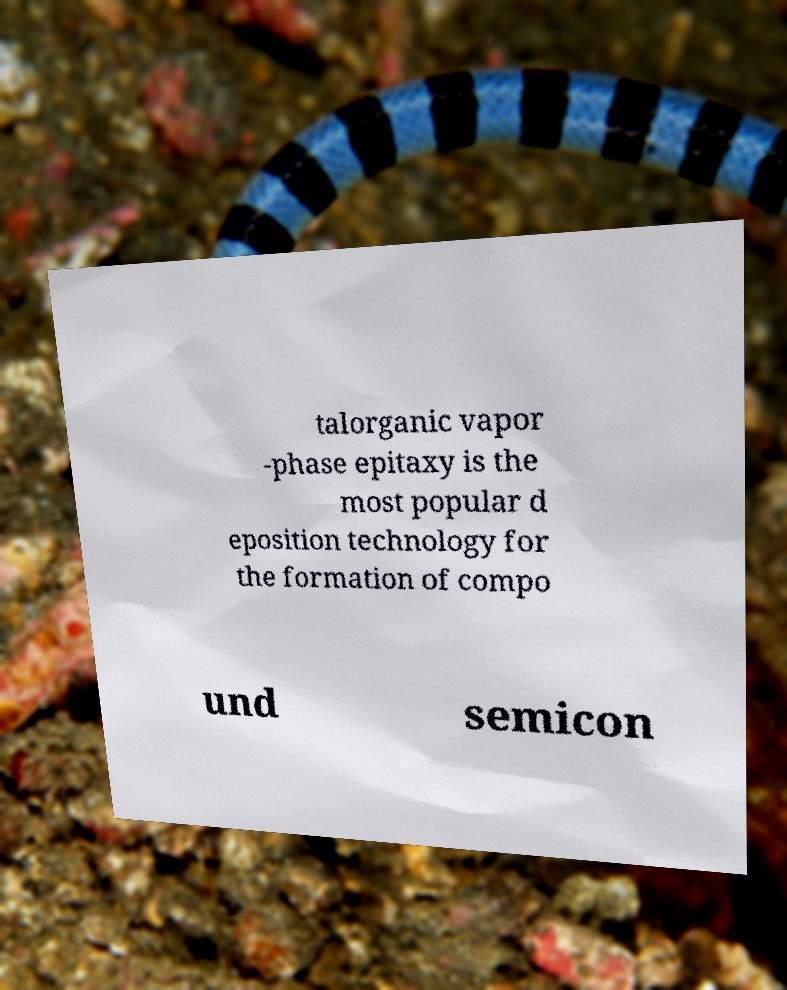What messages or text are displayed in this image? I need them in a readable, typed format. talorganic vapor -phase epitaxy is the most popular d eposition technology for the formation of compo und semicon 